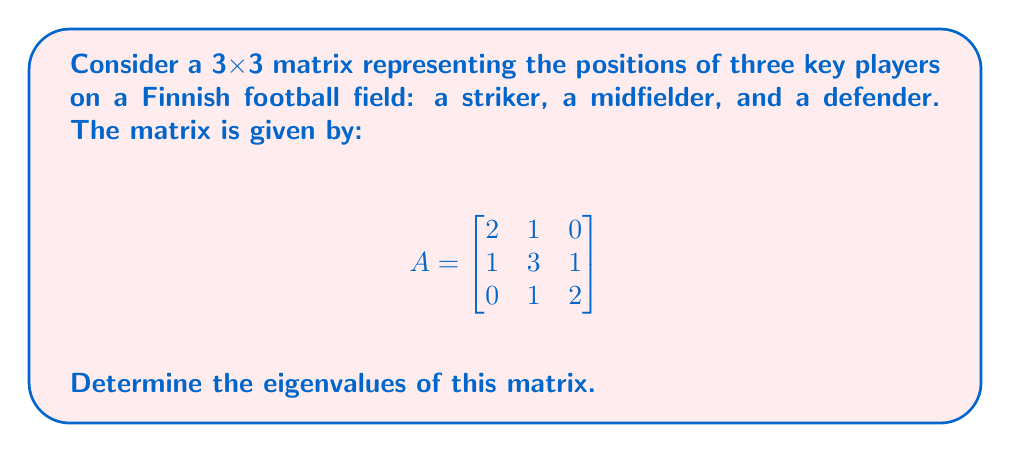Can you answer this question? To find the eigenvalues of matrix A, we need to solve the characteristic equation:

1. Set up the characteristic equation:
   $det(A - \lambda I) = 0$, where I is the 3x3 identity matrix.

2. Expand the determinant:
   $$det\begin{bmatrix}
   2-\lambda & 1 & 0 \\
   1 & 3-\lambda & 1 \\
   0 & 1 & 2-\lambda
   \end{bmatrix} = 0$$

3. Calculate the determinant:
   $(2-\lambda)[(3-\lambda)(2-\lambda) - 1] - 1[1(2-\lambda) - 0] = 0$

4. Simplify:
   $(2-\lambda)[(6-5\lambda+\lambda^2) - 1] - [2-\lambda] = 0$
   $(2-\lambda)(5-5\lambda+\lambda^2) - (2-\lambda) = 0$
   $10-10\lambda+2\lambda^2-5\lambda+5\lambda^2-\lambda^3 - 2 + \lambda = 0$

5. Rearrange to standard form:
   $-\lambda^3 + 7\lambda^2 - 14\lambda + 8 = 0$

6. Factor the equation:
   $-(\lambda - 1)(\lambda - 2)(\lambda - 4) = 0$

7. Solve for λ:
   $\lambda = 1, 2,$ or $4$

These are the eigenvalues of the matrix A.
Answer: $\lambda = 1, 2, 4$ 